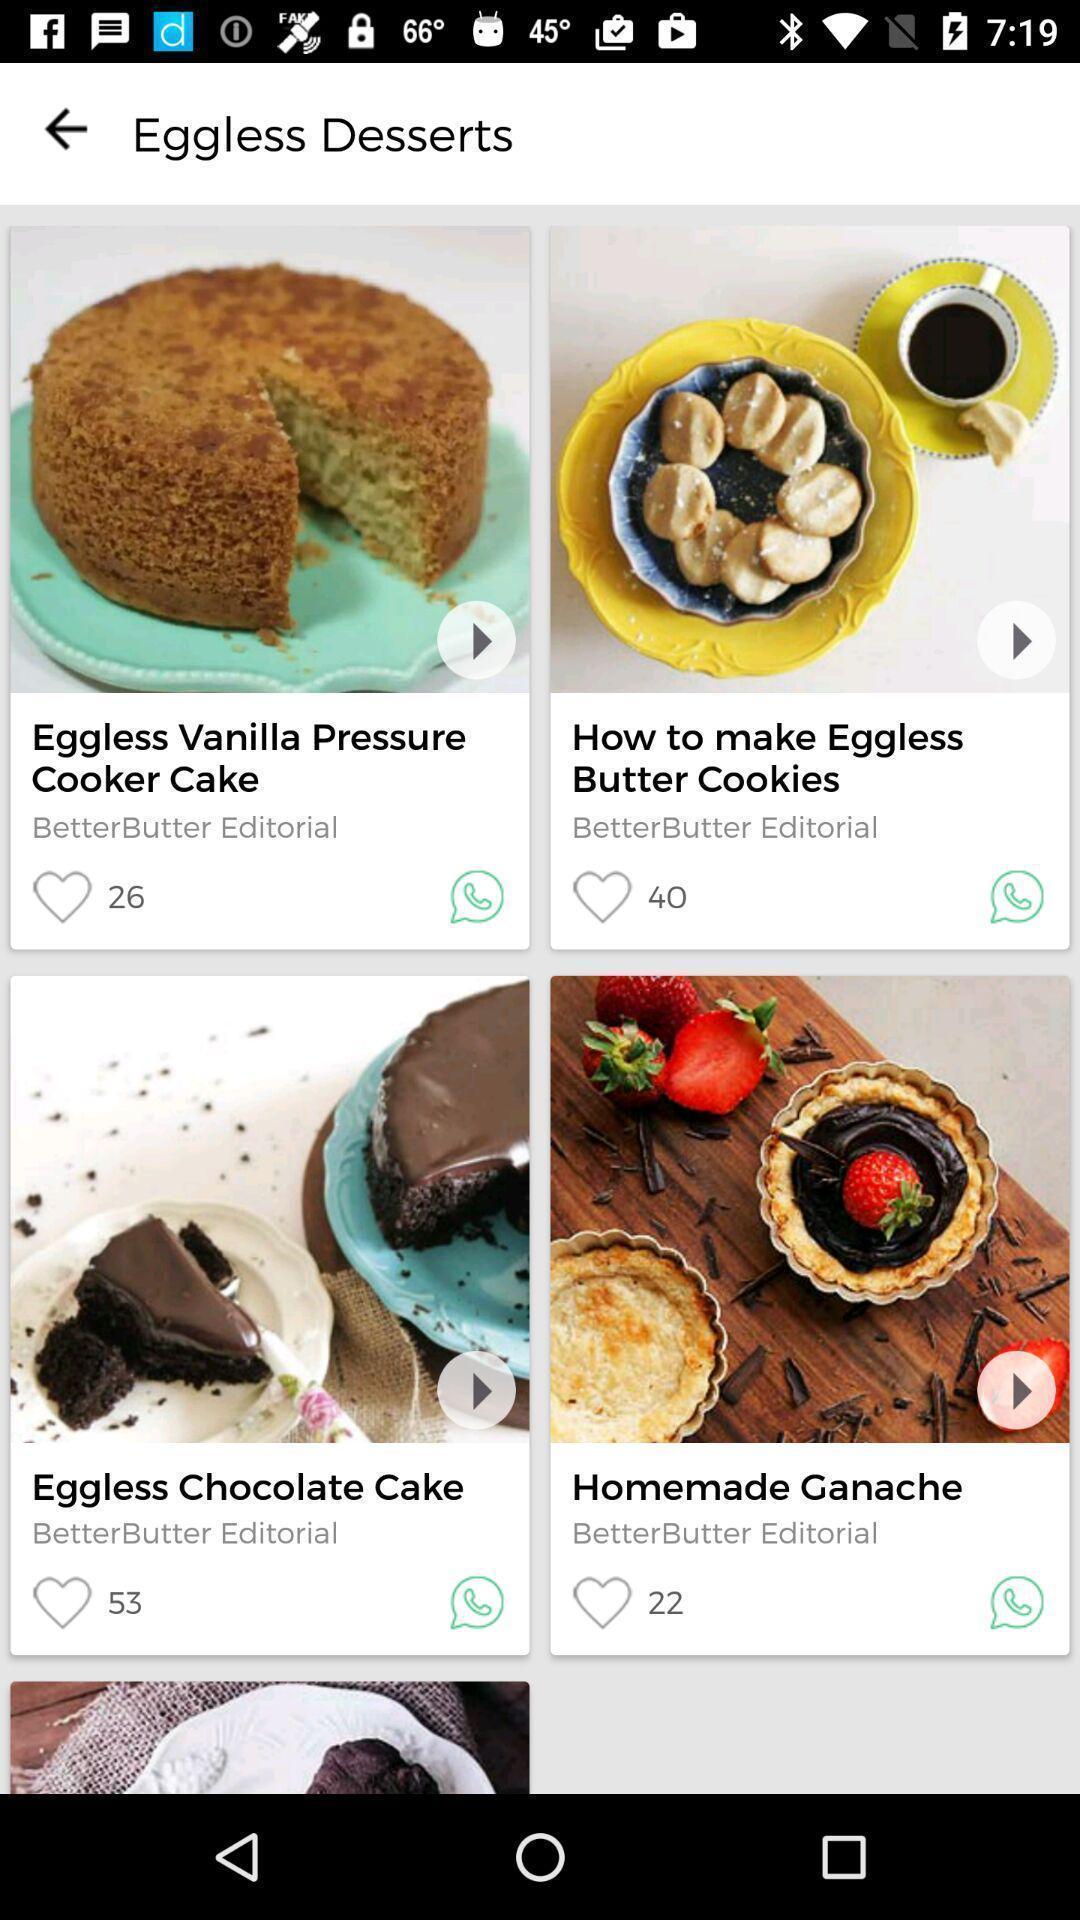Provide a textual representation of this image. Various recipes of a dessert displayed of an eatery app. 